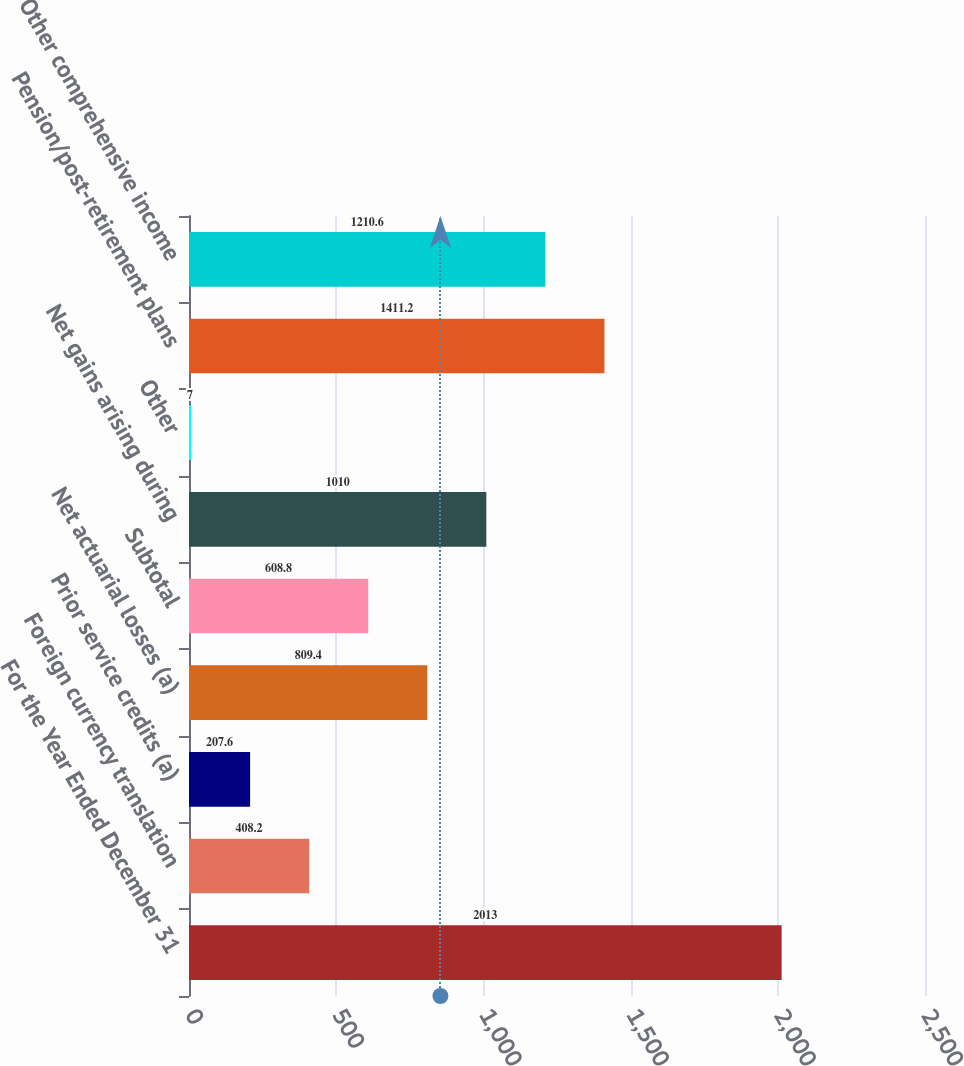Convert chart. <chart><loc_0><loc_0><loc_500><loc_500><bar_chart><fcel>For the Year Ended December 31<fcel>Foreign currency translation<fcel>Prior service credits (a)<fcel>Net actuarial losses (a)<fcel>Subtotal<fcel>Net gains arising during<fcel>Other<fcel>Pension/post-retirement plans<fcel>Other comprehensive income<nl><fcel>2013<fcel>408.2<fcel>207.6<fcel>809.4<fcel>608.8<fcel>1010<fcel>7<fcel>1411.2<fcel>1210.6<nl></chart> 